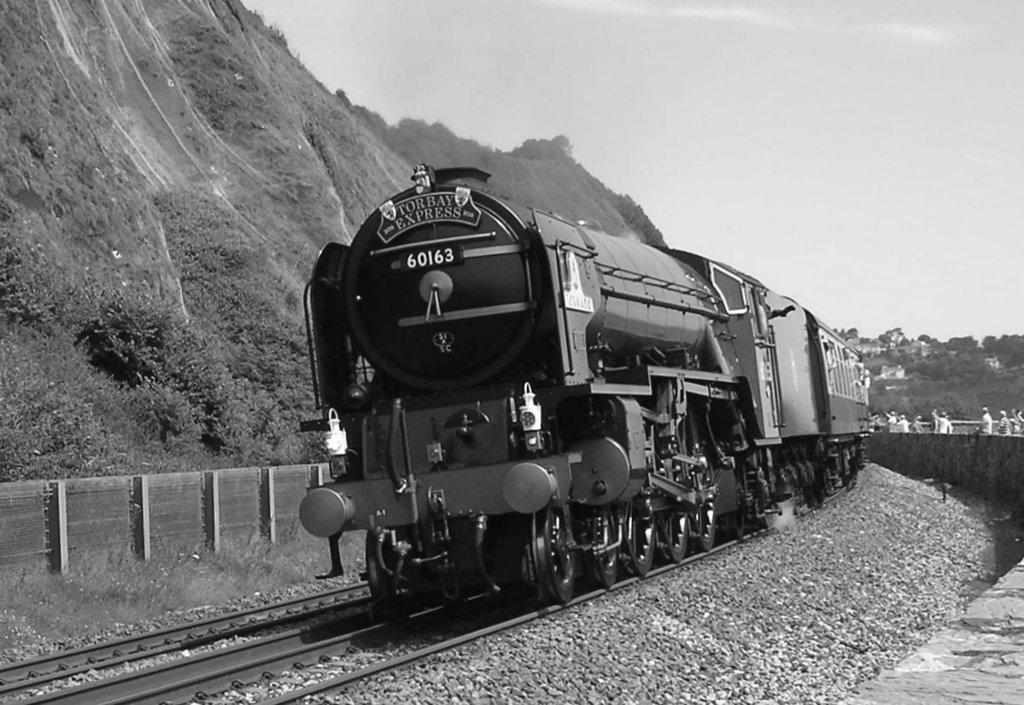What is the color scheme of the image? The image is black and white. What is the main subject of the image? A train is moving in the image. Where is the train located in the image? The train is on a track. What can be seen on the left side of the image? There is a hill on the left side of the image. How does the train express regret in the image? Trains do not have the ability to express regret, as they are inanimate objects. What type of tail can be seen on the train in the image? There is no tail present on the train in the image. 